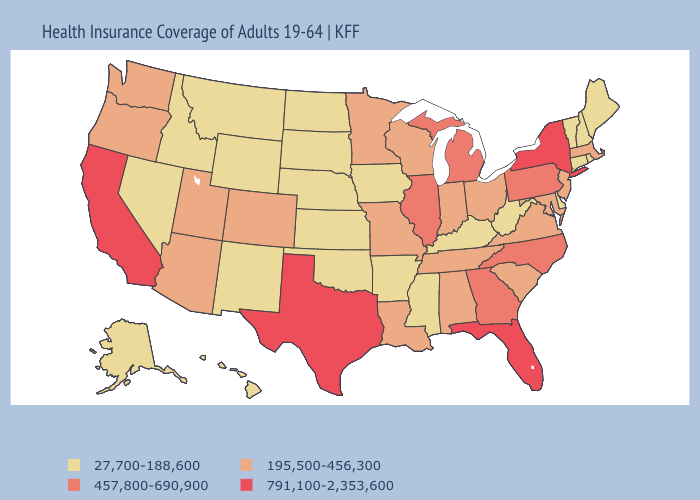What is the highest value in states that border Kentucky?
Short answer required. 457,800-690,900. Does Kansas have a lower value than Maine?
Answer briefly. No. Does the map have missing data?
Concise answer only. No. What is the value of Ohio?
Be succinct. 195,500-456,300. What is the lowest value in the USA?
Give a very brief answer. 27,700-188,600. Does New Hampshire have the highest value in the Northeast?
Answer briefly. No. Among the states that border Indiana , which have the lowest value?
Answer briefly. Kentucky. Does Utah have the same value as Vermont?
Be succinct. No. Does the first symbol in the legend represent the smallest category?
Concise answer only. Yes. What is the highest value in states that border Michigan?
Quick response, please. 195,500-456,300. What is the value of Virginia?
Short answer required. 195,500-456,300. Name the states that have a value in the range 791,100-2,353,600?
Short answer required. California, Florida, New York, Texas. Does the map have missing data?
Write a very short answer. No. Among the states that border Missouri , which have the lowest value?
Write a very short answer. Arkansas, Iowa, Kansas, Kentucky, Nebraska, Oklahoma. Among the states that border Wyoming , which have the highest value?
Give a very brief answer. Colorado, Utah. 